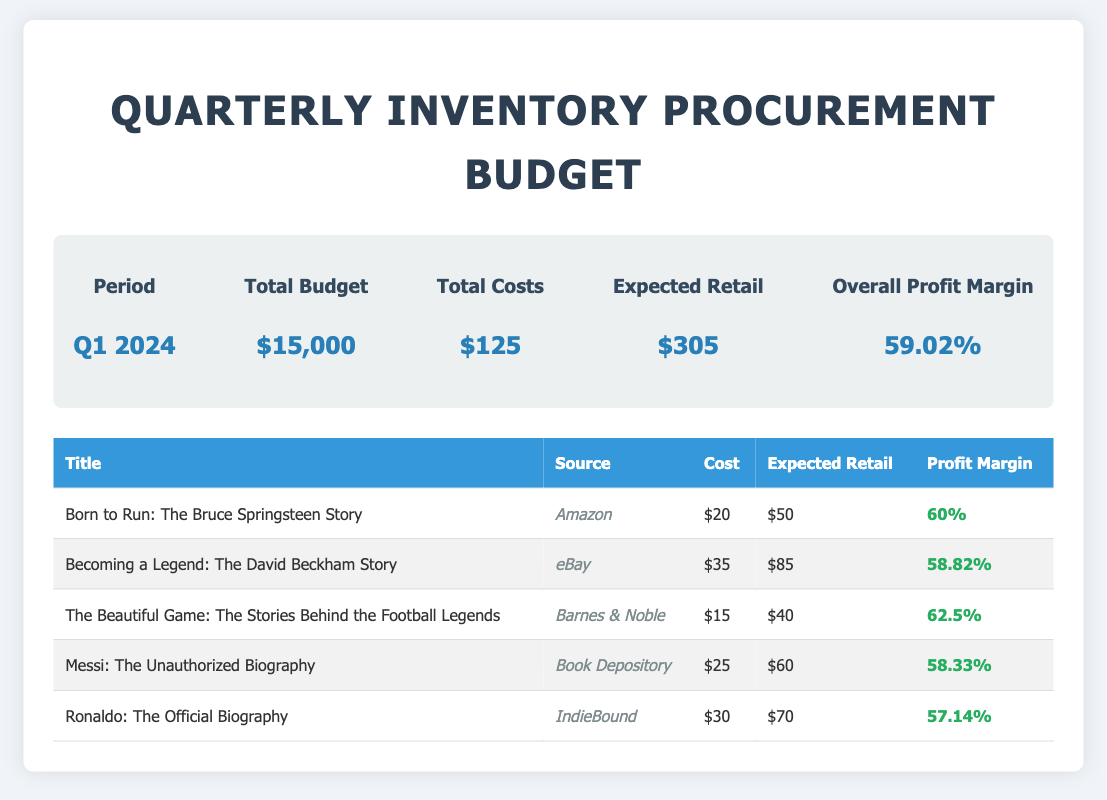What is the total budget for Q1 2024? The total budget is explicitly stated in the document as $15,000 for the specified quarter.
Answer: $15,000 What is the expected retail price of "Becoming a Legend: The David Beckham Story"? The expected retail price for this specific title is mentioned in the document, which is $85.
Answer: $85 Which source provides "Born to Run: The Bruce Springsteen Story"? The source listed in the document for this title is Amazon.
Answer: Amazon What is the profit margin for "The Beautiful Game: The Stories Behind the Football Legends"? The document states the profit margin for this title as 62.5%.
Answer: 62.5% What is the total cost for the inventory? The total cost is detailed in the document as $125.
Answer: $125 What is the overall profit margin for the quarter? The overall profit margin for Q1 2024 is clearly stated in the document as 59.02%.
Answer: 59.02% Where can you purchase "Messi: The Unauthorized Biography"? The document lists the source for this biography as Book Depository.
Answer: Book Depository What is the cost of "Ronaldo: The Official Biography"? The document specifies the cost of this biography as $30.
Answer: $30 